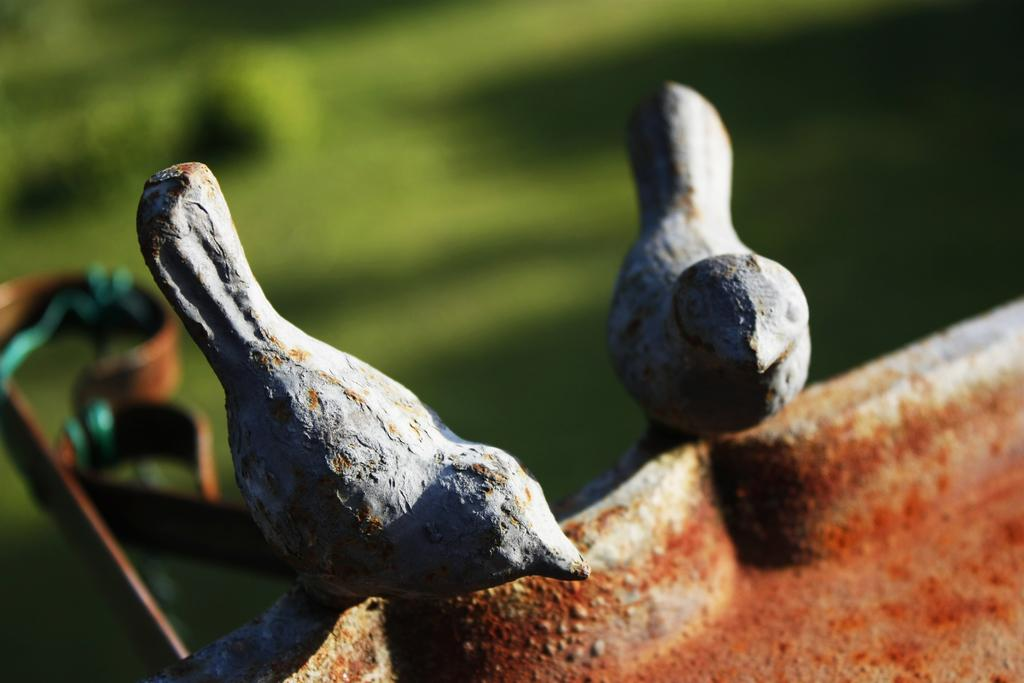How many birds are present in the image? There are two birds in the image. Where are the birds located? The birds are on a rock. What is behind the birds in the image? There is an object behind the birds. How would you describe the background of the image? The background of the image is blurred. What type of produce is being harvested by the crook in the image? There is no crook or produce present in the image; it features two birds on a rock with an object behind them and a blurred background. 